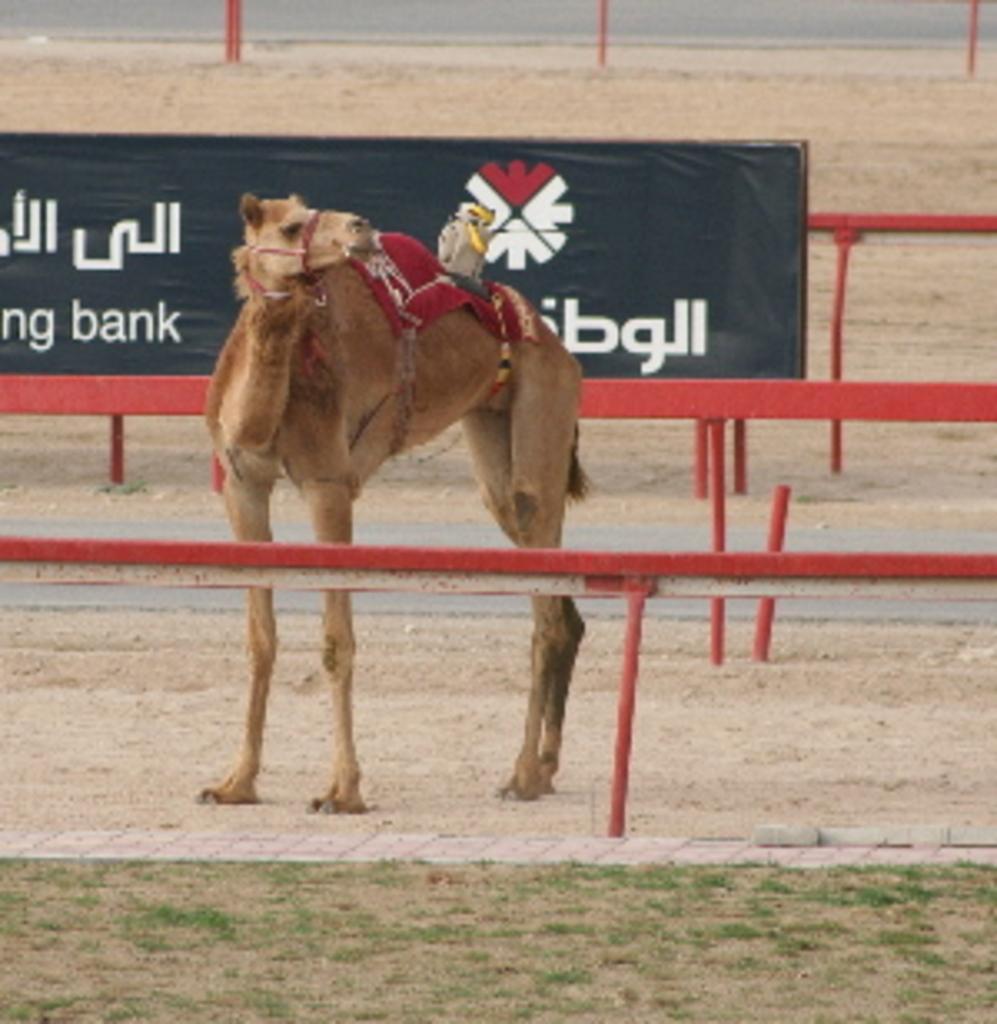Please provide a concise description of this image. In this image in the front there is grass. In the center there is a camel standing on the ground, there are railings and there is a board with some text written on it. In the background there is an object which is red in colour. 